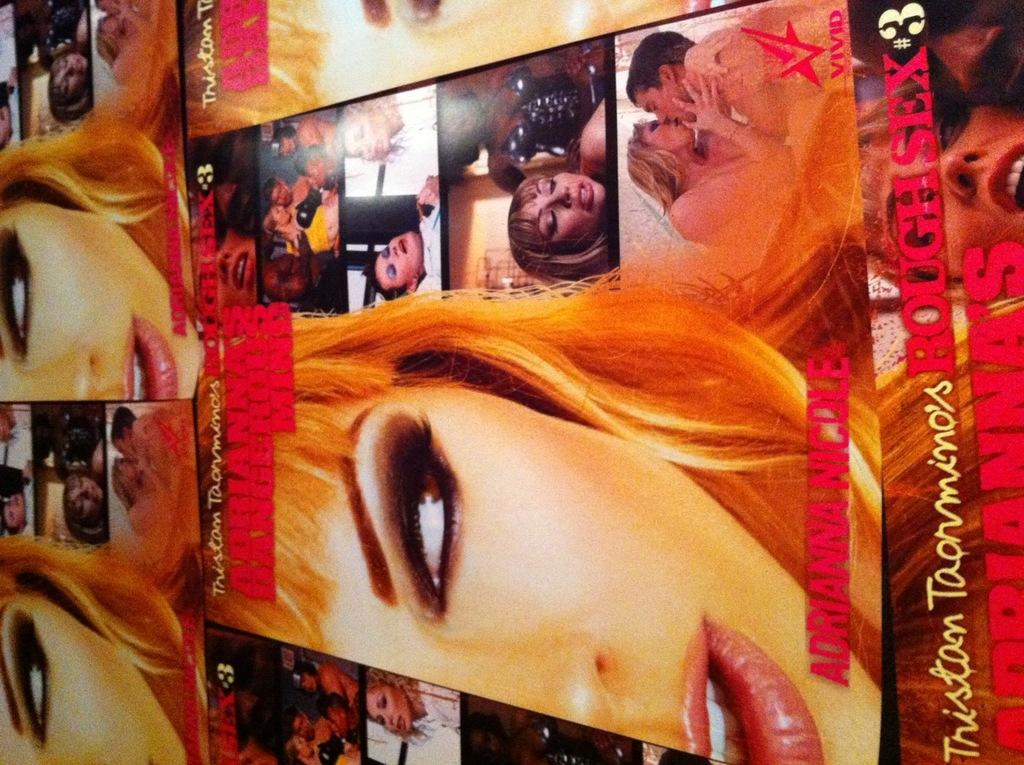<image>
Share a concise interpretation of the image provided. The cover of a pornographic film shows its title of Rough Sex #3. 